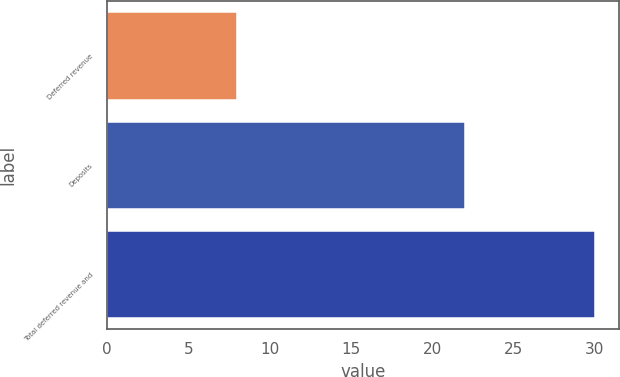<chart> <loc_0><loc_0><loc_500><loc_500><bar_chart><fcel>Deferred revenue<fcel>Deposits<fcel>Total deferred revenue and<nl><fcel>8<fcel>22<fcel>30<nl></chart> 